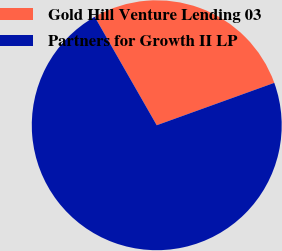<chart> <loc_0><loc_0><loc_500><loc_500><pie_chart><fcel>Gold Hill Venture Lending 03<fcel>Partners for Growth II LP<nl><fcel>27.76%<fcel>72.24%<nl></chart> 